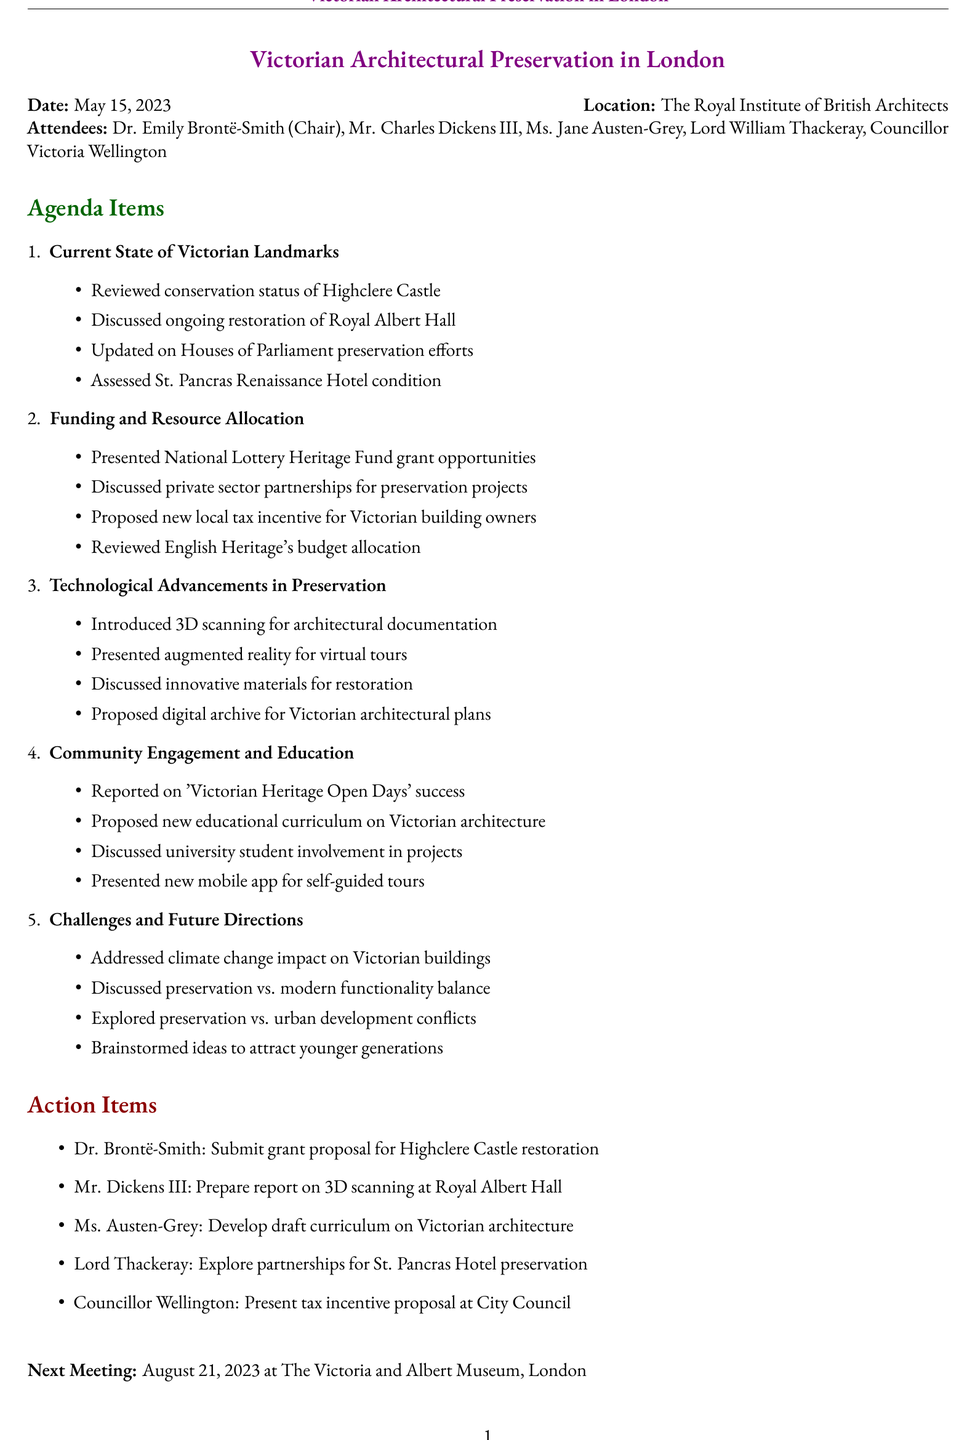What is the date of the meeting? The date of the meeting is clearly stated at the beginning of the document.
Answer: May 15, 2023 Who is the chair of the meeting? The document lists the attendees, and identifies the chair person.
Answer: Dr. Emily Brontë-Smith What is one significant ongoing restoration project mentioned? The agenda item concerning the current state of Victorian landmarks includes ongoing restoration projects.
Answer: Royal Albert Hall What new proposal was discussed regarding tax incentives? The document outlines a specific proposal made under the funding and resource allocation section.
Answer: New local tax incentive for Victorian building owners What technology was introduced for architectural documentation? The technological advancements section mentions specific techniques introduced at the meeting.
Answer: 3D scanning Who will develop a draft curriculum? Action items state who is responsible for developing the draft.
Answer: Ms. Austen-Grey When is the next meeting scheduled? The document contains a section about the next meeting with details on its date.
Answer: August 21, 2023 What successful program was reported on? Community engagement mentions a program linked to Victorian heritage that was deemed successful.
Answer: Victorian Heritage Open Days What challenge related to climate change was addressed? The challenges section discusses specific issues, including one related to climate change.
Answer: Impact on Victorian buildings 